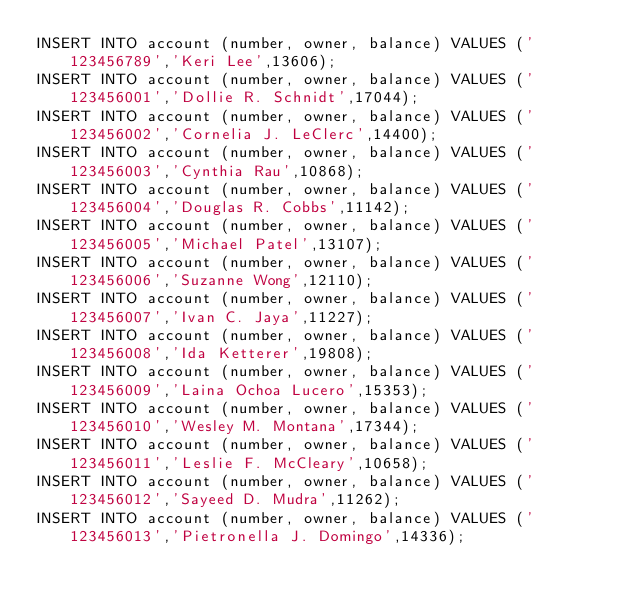<code> <loc_0><loc_0><loc_500><loc_500><_SQL_>INSERT INTO account (number, owner, balance) VALUES ('123456789','Keri Lee',13606);
INSERT INTO account (number, owner, balance) VALUES ('123456001','Dollie R. Schnidt',17044);
INSERT INTO account (number, owner, balance) VALUES ('123456002','Cornelia J. LeClerc',14400);
INSERT INTO account (number, owner, balance) VALUES ('123456003','Cynthia Rau',10868);
INSERT INTO account (number, owner, balance) VALUES ('123456004','Douglas R. Cobbs',11142);
INSERT INTO account (number, owner, balance) VALUES ('123456005','Michael Patel',13107);
INSERT INTO account (number, owner, balance) VALUES ('123456006','Suzanne Wong',12110);
INSERT INTO account (number, owner, balance) VALUES ('123456007','Ivan C. Jaya',11227);
INSERT INTO account (number, owner, balance) VALUES ('123456008','Ida Ketterer',19808);
INSERT INTO account (number, owner, balance) VALUES ('123456009','Laina Ochoa Lucero',15353);
INSERT INTO account (number, owner, balance) VALUES ('123456010','Wesley M. Montana',17344);
INSERT INTO account (number, owner, balance) VALUES ('123456011','Leslie F. McCleary',10658);
INSERT INTO account (number, owner, balance) VALUES ('123456012','Sayeed D. Mudra',11262);
INSERT INTO account (number, owner, balance) VALUES ('123456013','Pietronella J. Domingo',14336);</code> 